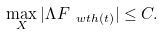<formula> <loc_0><loc_0><loc_500><loc_500>\max _ { X } | \Lambda F _ { \ w t { h } ( t ) } | \leq C .</formula> 